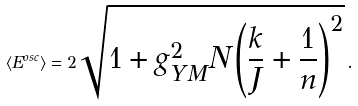Convert formula to latex. <formula><loc_0><loc_0><loc_500><loc_500>\langle E ^ { o s c } \rangle = 2 \sqrt { 1 + g ^ { 2 } _ { Y M } N \left ( \frac { k } { J } + \frac { 1 } { n } \right ) ^ { 2 } } \, .</formula> 